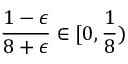Convert formula to latex. <formula><loc_0><loc_0><loc_500><loc_500>\frac { 1 - \epsilon } { 8 + \epsilon } \in [ 0 , \frac { 1 } { 8 } )</formula> 